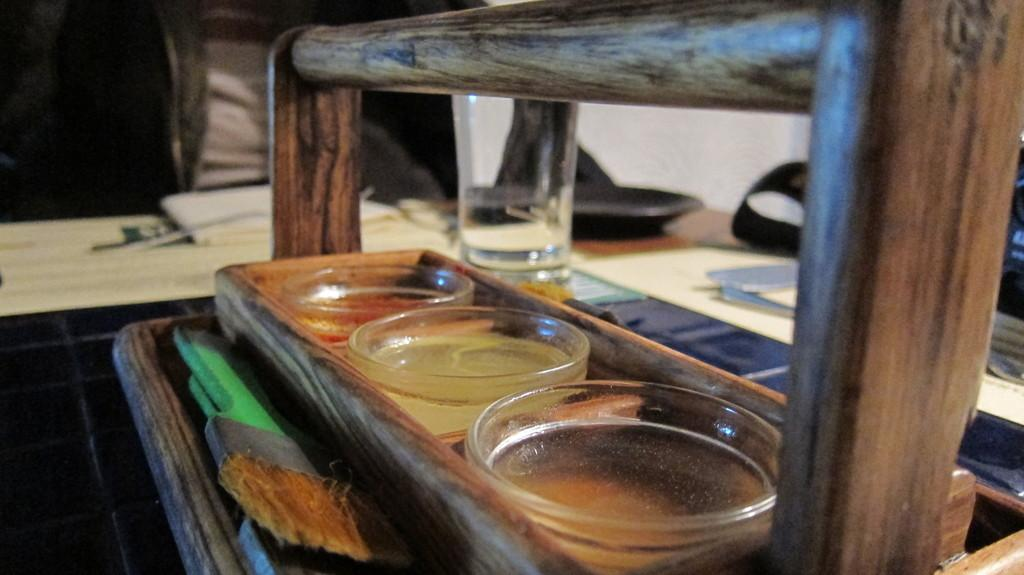What is the main piece of furniture in the image? There is a table in the image. What is placed on the table? There is a wooden tray on the table. What can be found inside the wooden tray? There are glasses in the wooden tray. Where is another glass located in the image? There is a glass beside the tree. How would you describe the background of the image? The background of the image is blurred. What type of insurance policy is being discussed in the image? There is no discussion of insurance policies in the image; it features a table, a wooden tray, glasses, and a blurred background. How many frogs can be seen in the image? There are no frogs present in the image. 